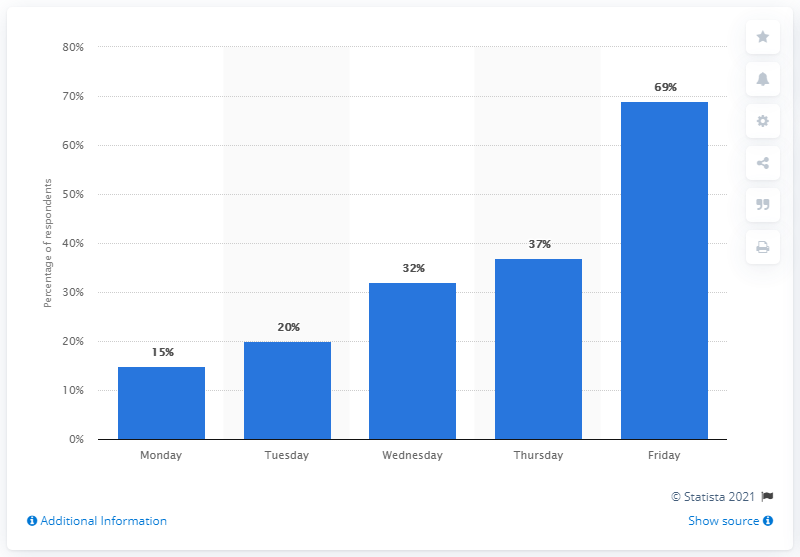Identify some key points in this picture. Friday was the most popular night for happy hour in the United States. 